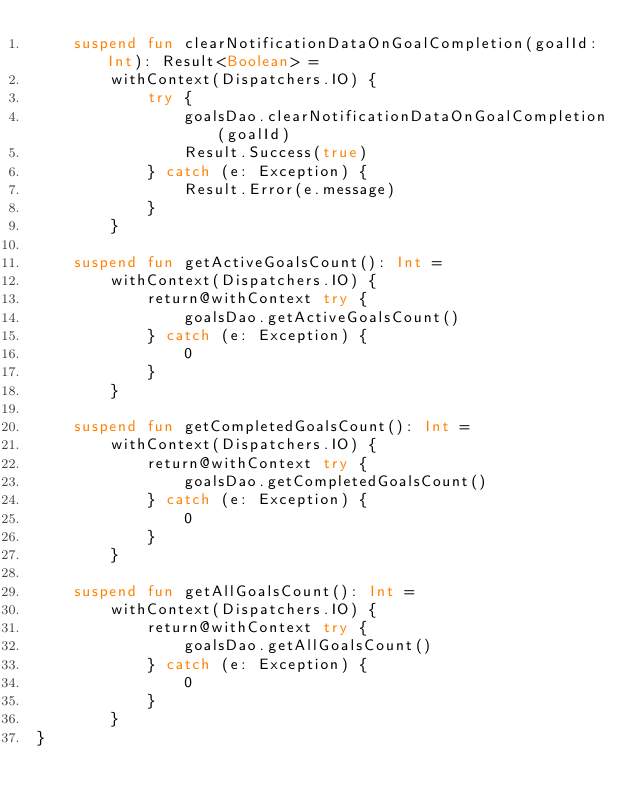Convert code to text. <code><loc_0><loc_0><loc_500><loc_500><_Kotlin_>    suspend fun clearNotificationDataOnGoalCompletion(goalId: Int): Result<Boolean> =
        withContext(Dispatchers.IO) {
            try {
                goalsDao.clearNotificationDataOnGoalCompletion(goalId)
                Result.Success(true)
            } catch (e: Exception) {
                Result.Error(e.message)
            }
        }

    suspend fun getActiveGoalsCount(): Int =
        withContext(Dispatchers.IO) {
            return@withContext try {
                goalsDao.getActiveGoalsCount()
            } catch (e: Exception) {
                0
            }
        }

    suspend fun getCompletedGoalsCount(): Int =
        withContext(Dispatchers.IO) {
            return@withContext try {
                goalsDao.getCompletedGoalsCount()
            } catch (e: Exception) {
                0
            }
        }

    suspend fun getAllGoalsCount(): Int =
        withContext(Dispatchers.IO) {
            return@withContext try {
                goalsDao.getAllGoalsCount()
            } catch (e: Exception) {
                0
            }
        }
}


</code> 